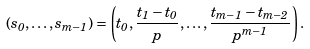Convert formula to latex. <formula><loc_0><loc_0><loc_500><loc_500>( s _ { 0 } , \dots , s _ { m - 1 } ) = \left ( t _ { 0 } , \frac { t _ { 1 } - t _ { 0 } } p , \dots , \frac { t _ { m - 1 } - t _ { m - 2 } } { p ^ { m - 1 } } \right ) .</formula> 